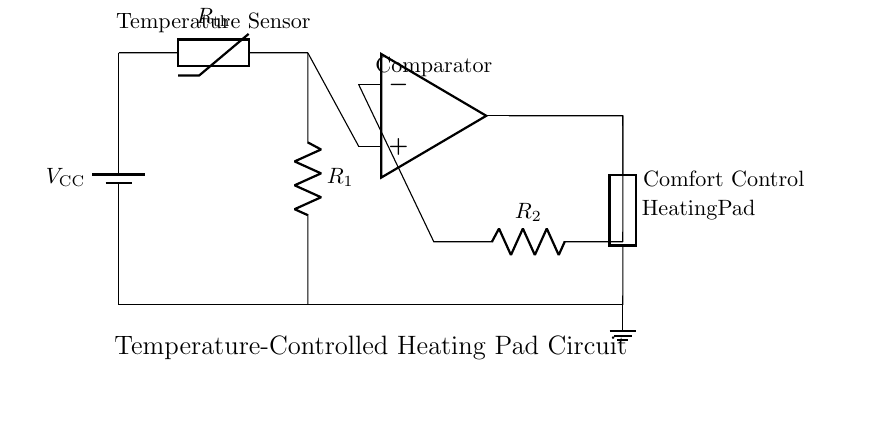What is the purpose of the thermistor? The thermistor serves as a temperature sensor, responding to changes in temperature by altering its resistance, which helps control the heating pad's temperature.
Answer: Temperature sensor What type of component is connected to the output of the op-amp? The output of the op-amp is connected to a generic heating pad, indicating that the op-amp controls the heating element based on the temperature reading from the thermistor.
Answer: Heating pad What is the role of the resistors in the circuit? The resistors are part of a voltage divider network, with one resistor connected to the thermistor and the other in the feedback loop of the op-amp. They help set the reference voltage levels for proper operation of the op-amp.
Answer: Voltage divider How many resistors are present in this circuit? There are two resistors in the circuit: R1 and R2, which play important roles in voltage sensing and feedback for the op-amp.
Answer: Two What does the op-amp compare in this circuit? The op-amp compares the voltage generated by the thermistor and resistor with a reference voltage, allowing it to control the heating pad to maintain comfort based on the sensed temperature.
Answer: Voltage What would happen if the thermistor's resistance decreases? If the thermistor's resistance decreases (due to an increase in temperature), the voltage at the op-amp's positive input will change, which could prompt the op-amp to adjust the output accordingly, potentially increasing heating to maintain comfort.
Answer: Increase heating What is the voltage supply to the circuit? The circuit is powered by a battery labeled V_CC, although the exact voltage value is not specified in the diagram.
Answer: V_CC 